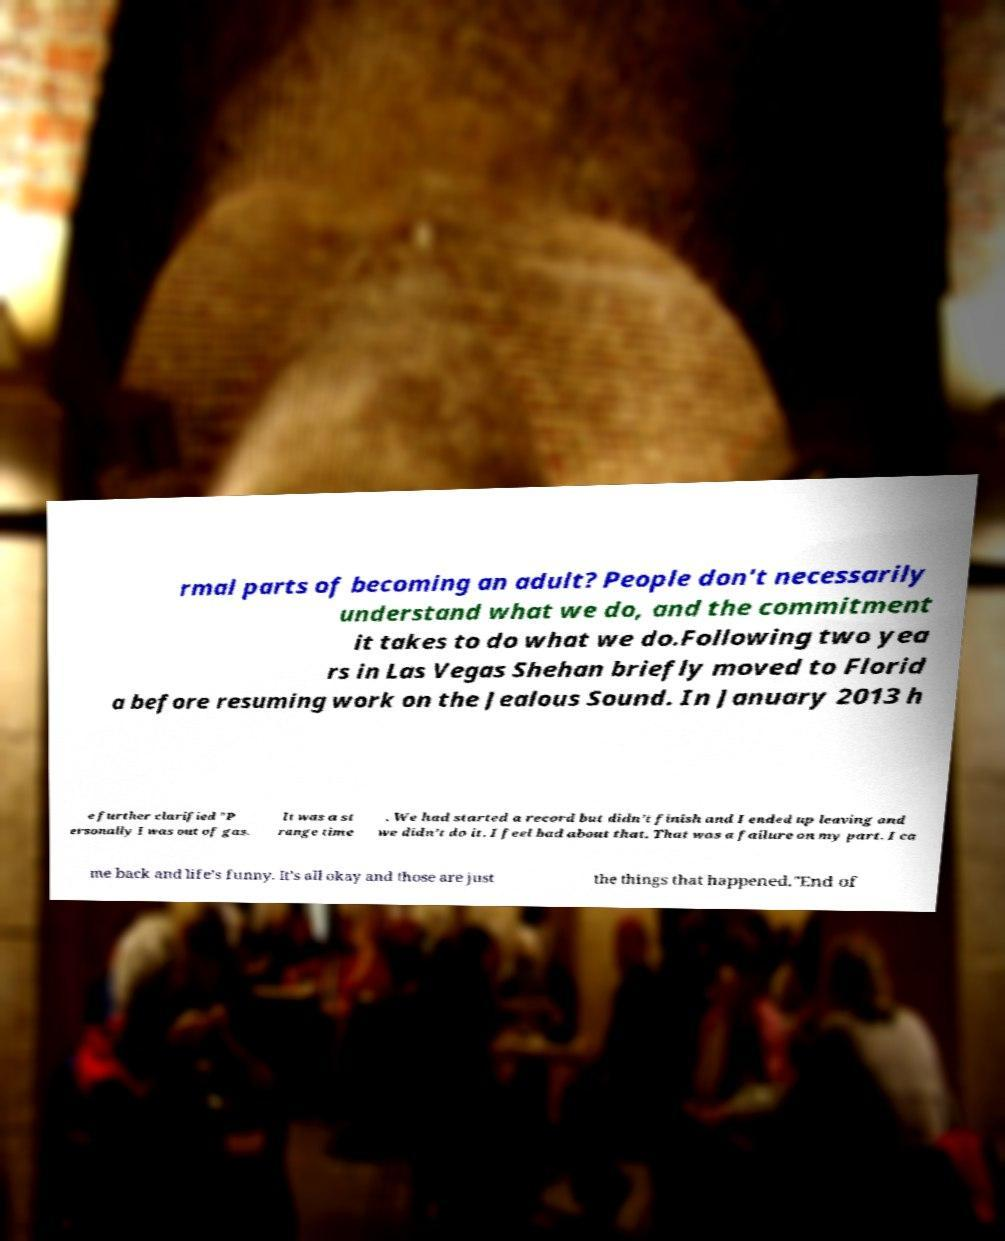Please identify and transcribe the text found in this image. rmal parts of becoming an adult? People don't necessarily understand what we do, and the commitment it takes to do what we do.Following two yea rs in Las Vegas Shehan briefly moved to Florid a before resuming work on the Jealous Sound. In January 2013 h e further clarified "P ersonally I was out of gas. It was a st range time . We had started a record but didn’t finish and I ended up leaving and we didn’t do it. I feel bad about that. That was a failure on my part. I ca me back and life’s funny. It’s all okay and those are just the things that happened."End of 